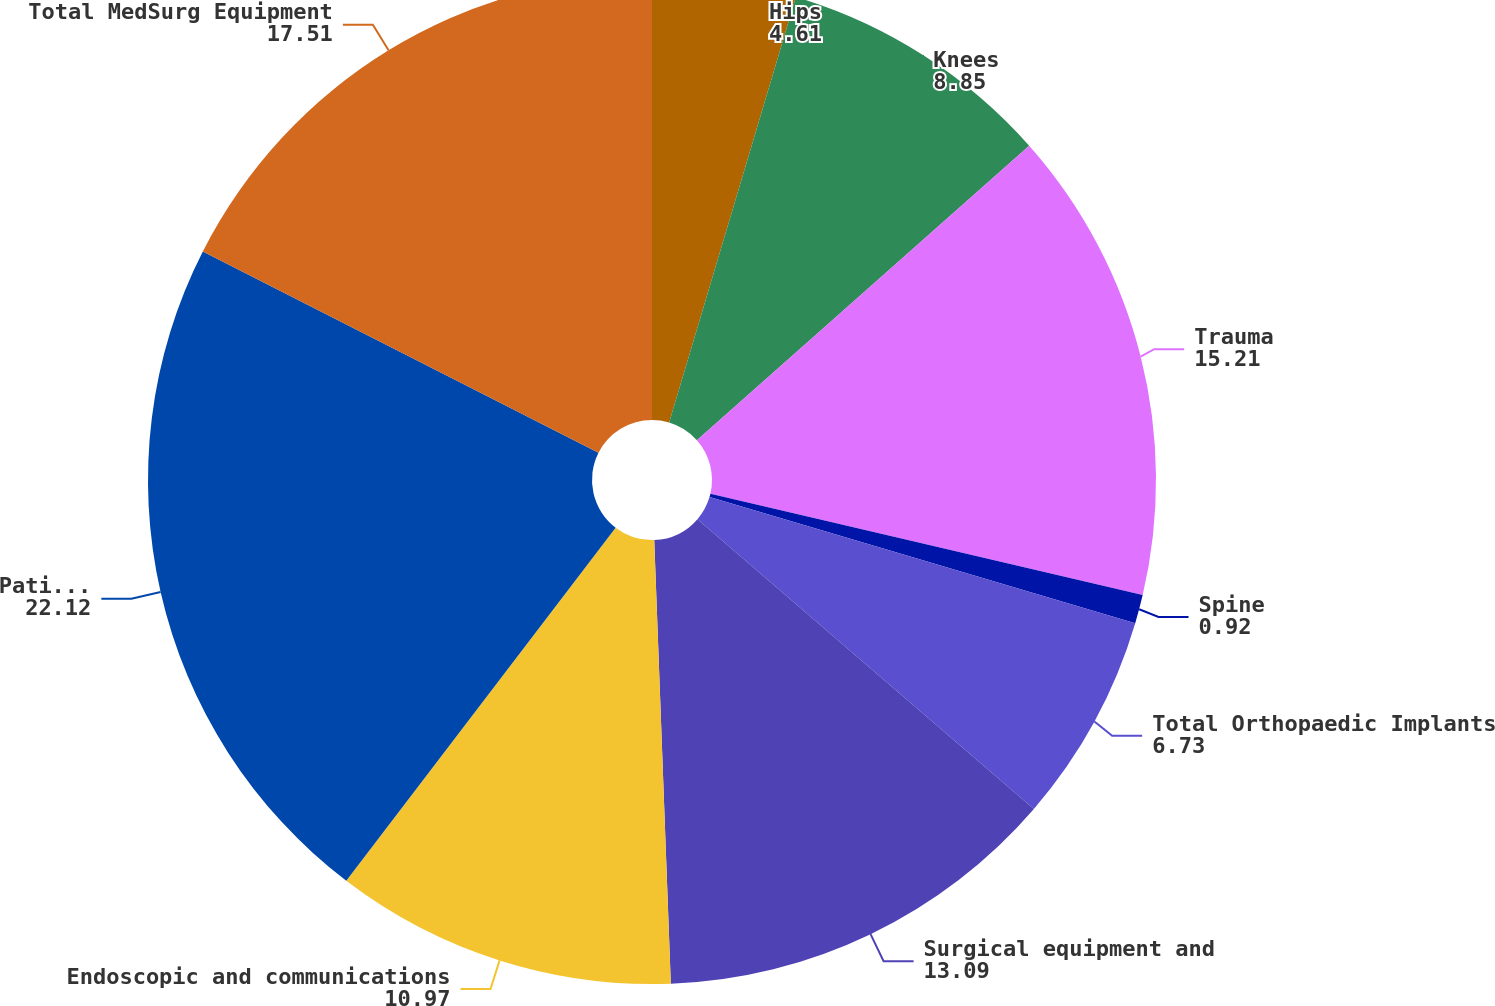Convert chart to OTSL. <chart><loc_0><loc_0><loc_500><loc_500><pie_chart><fcel>Hips<fcel>Knees<fcel>Trauma<fcel>Spine<fcel>Total Orthopaedic Implants<fcel>Surgical equipment and<fcel>Endoscopic and communications<fcel>Patient handling and emergency<fcel>Total MedSurg Equipment<nl><fcel>4.61%<fcel>8.85%<fcel>15.21%<fcel>0.92%<fcel>6.73%<fcel>13.09%<fcel>10.97%<fcel>22.12%<fcel>17.51%<nl></chart> 